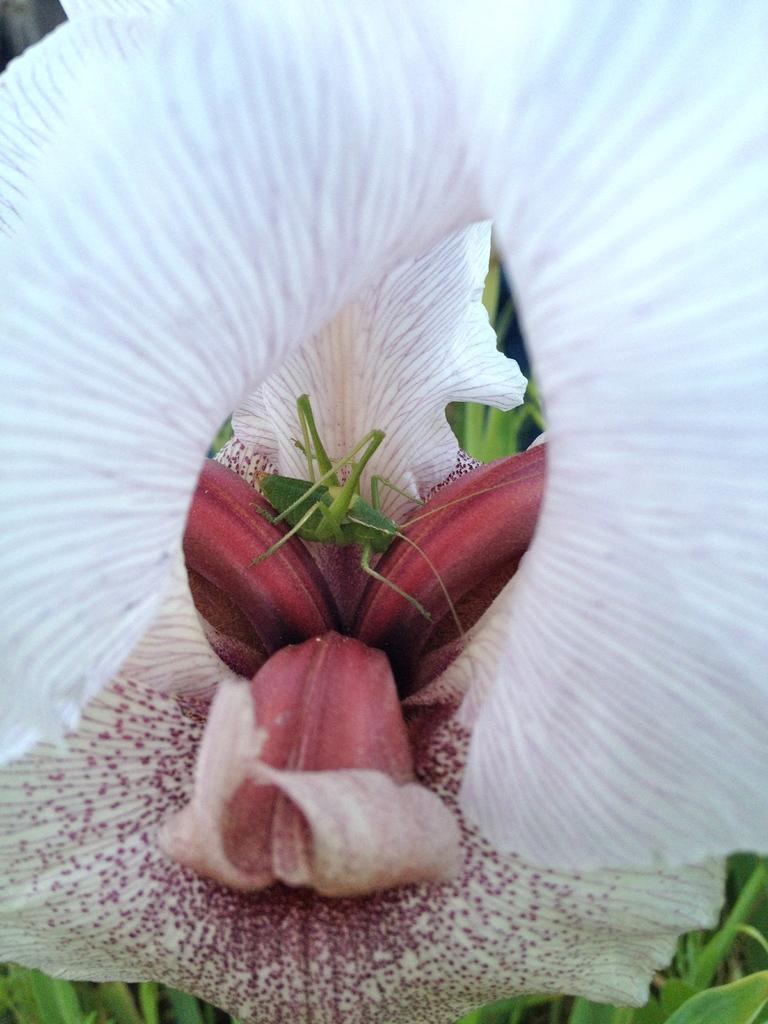Please provide a concise description of this image. In this image I can see a white and peach color flower. Inside I can see a green color insect. Back I can see few green leaves. 